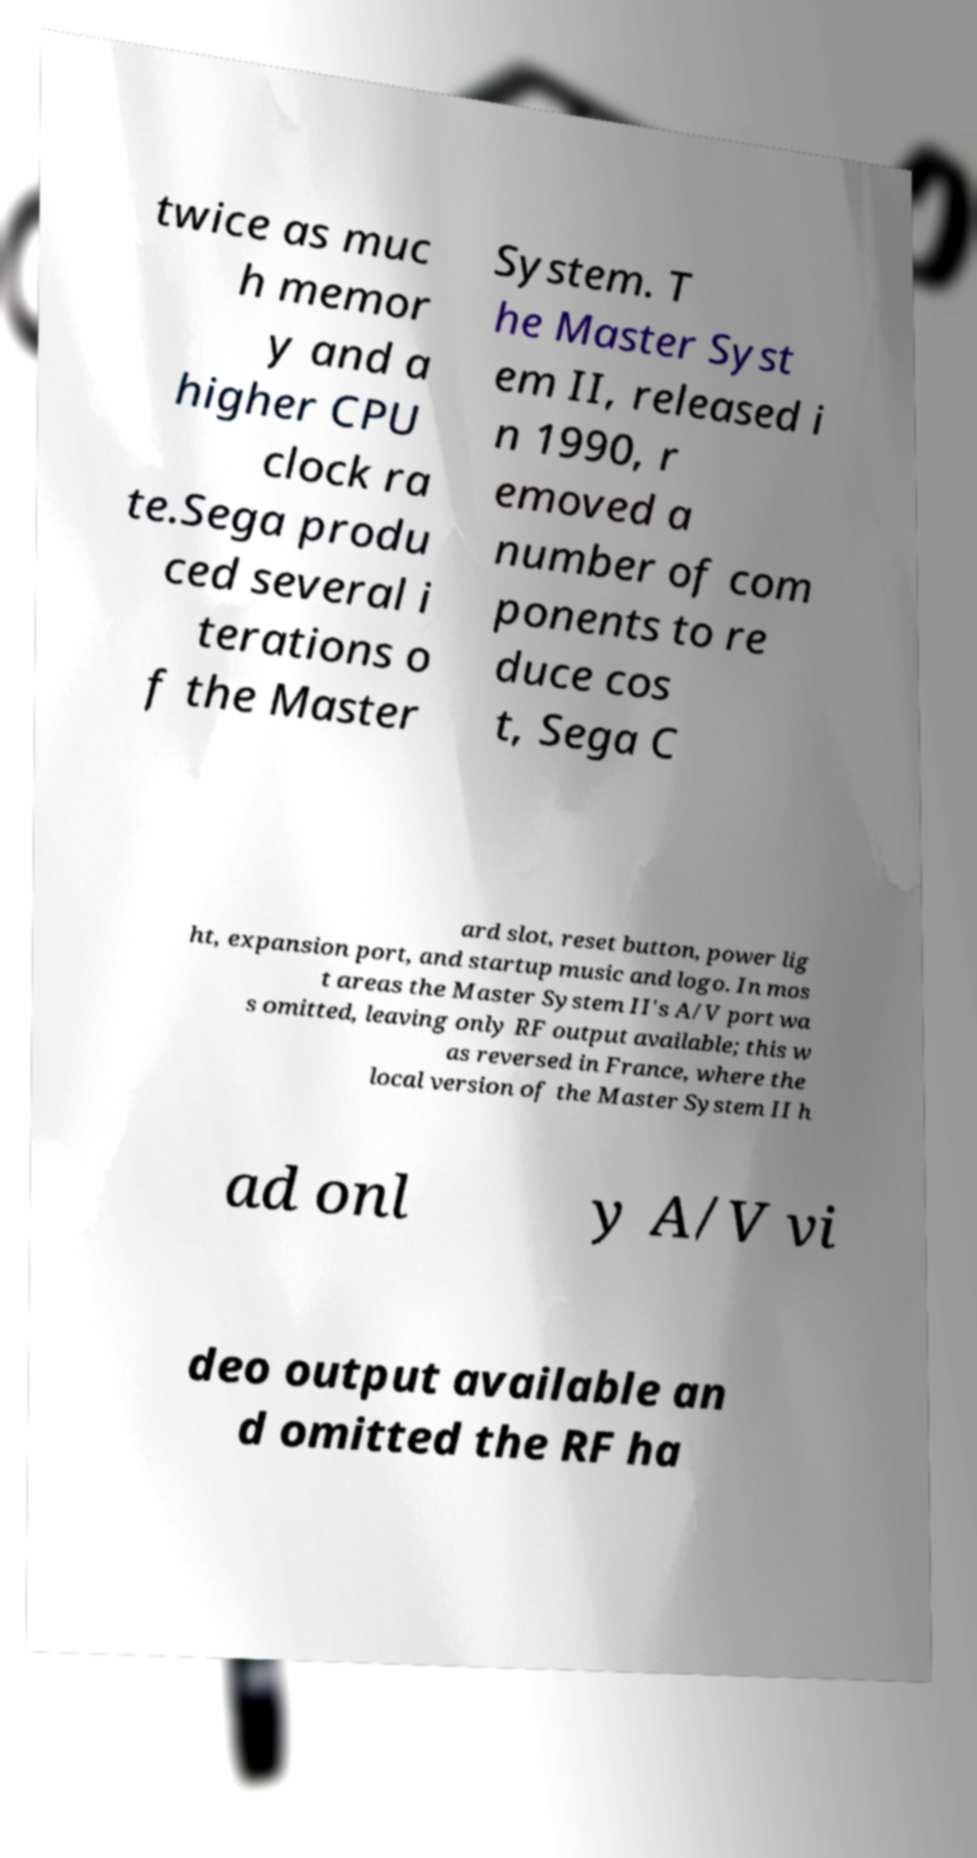Could you extract and type out the text from this image? twice as muc h memor y and a higher CPU clock ra te.Sega produ ced several i terations o f the Master System. T he Master Syst em II, released i n 1990, r emoved a number of com ponents to re duce cos t, Sega C ard slot, reset button, power lig ht, expansion port, and startup music and logo. In mos t areas the Master System II's A/V port wa s omitted, leaving only RF output available; this w as reversed in France, where the local version of the Master System II h ad onl y A/V vi deo output available an d omitted the RF ha 